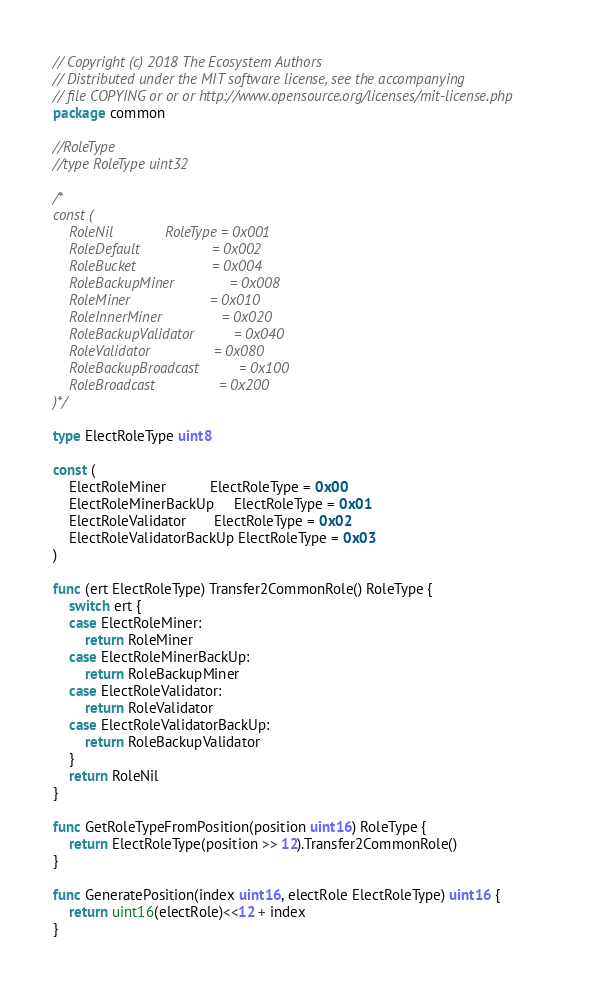Convert code to text. <code><loc_0><loc_0><loc_500><loc_500><_Go_>// Copyright (c) 2018 The Ecosystem Authors
// Distributed under the MIT software license, see the accompanying
// file COPYING or or or http://www.opensource.org/licenses/mit-license.php
package common

//RoleType
//type RoleType uint32

/*
const (
	RoleNil             RoleType = 0x001
	RoleDefault                  = 0x002
	RoleBucket                   = 0x004
	RoleBackupMiner              = 0x008
	RoleMiner                    = 0x010
	RoleInnerMiner               = 0x020
	RoleBackupValidator          = 0x040
	RoleValidator                = 0x080
	RoleBackupBroadcast          = 0x100
	RoleBroadcast                = 0x200
)*/

type ElectRoleType uint8

const (
	ElectRoleMiner           ElectRoleType = 0x00
	ElectRoleMinerBackUp     ElectRoleType = 0x01
	ElectRoleValidator       ElectRoleType = 0x02
	ElectRoleValidatorBackUp ElectRoleType = 0x03
)

func (ert ElectRoleType) Transfer2CommonRole() RoleType {
	switch ert {
	case ElectRoleMiner:
		return RoleMiner
	case ElectRoleMinerBackUp:
		return RoleBackupMiner
	case ElectRoleValidator:
		return RoleValidator
	case ElectRoleValidatorBackUp:
		return RoleBackupValidator
	}
	return RoleNil
}

func GetRoleTypeFromPosition(position uint16) RoleType {
	return ElectRoleType(position >> 12).Transfer2CommonRole()
}

func GeneratePosition(index uint16, electRole ElectRoleType) uint16 {
	return uint16(electRole)<<12 + index
}
</code> 